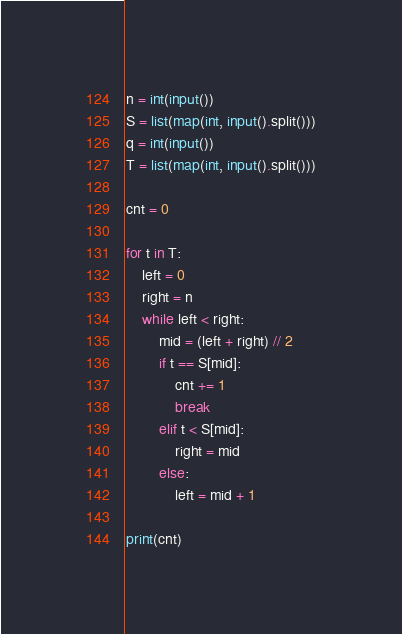Convert code to text. <code><loc_0><loc_0><loc_500><loc_500><_Python_>n = int(input())
S = list(map(int, input().split()))
q = int(input())
T = list(map(int, input().split()))

cnt = 0

for t in T:
    left = 0
    right = n
    while left < right:
        mid = (left + right) // 2
        if t == S[mid]:
            cnt += 1
            break
        elif t < S[mid]:
            right = mid
        else:
            left = mid + 1
            
print(cnt)
</code> 